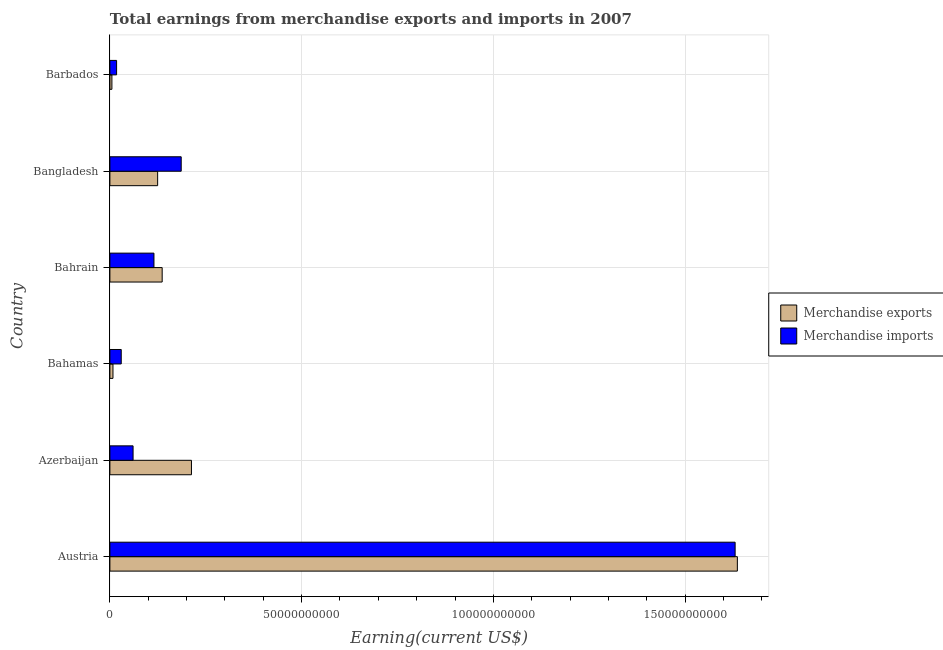How many different coloured bars are there?
Ensure brevity in your answer.  2. Are the number of bars per tick equal to the number of legend labels?
Offer a terse response. Yes. How many bars are there on the 6th tick from the top?
Ensure brevity in your answer.  2. In how many cases, is the number of bars for a given country not equal to the number of legend labels?
Your answer should be very brief. 0. What is the earnings from merchandise imports in Azerbaijan?
Keep it short and to the point. 6.05e+09. Across all countries, what is the maximum earnings from merchandise imports?
Keep it short and to the point. 1.63e+11. Across all countries, what is the minimum earnings from merchandise imports?
Offer a very short reply. 1.75e+09. In which country was the earnings from merchandise imports minimum?
Give a very brief answer. Barbados. What is the total earnings from merchandise exports in the graph?
Keep it short and to the point. 2.12e+11. What is the difference between the earnings from merchandise imports in Austria and that in Bahamas?
Offer a terse response. 1.60e+11. What is the difference between the earnings from merchandise exports in Bangladesh and the earnings from merchandise imports in Bahamas?
Ensure brevity in your answer.  9.50e+09. What is the average earnings from merchandise exports per country?
Keep it short and to the point. 3.54e+1. What is the difference between the earnings from merchandise exports and earnings from merchandise imports in Bahrain?
Provide a short and direct response. 2.15e+09. In how many countries, is the earnings from merchandise exports greater than 80000000000 US$?
Provide a short and direct response. 1. What is the ratio of the earnings from merchandise imports in Bahamas to that in Bahrain?
Provide a short and direct response. 0.26. Is the difference between the earnings from merchandise exports in Azerbaijan and Barbados greater than the difference between the earnings from merchandise imports in Azerbaijan and Barbados?
Provide a succinct answer. Yes. What is the difference between the highest and the second highest earnings from merchandise exports?
Make the answer very short. 1.42e+11. What is the difference between the highest and the lowest earnings from merchandise exports?
Keep it short and to the point. 1.63e+11. How many countries are there in the graph?
Provide a succinct answer. 6. What is the difference between two consecutive major ticks on the X-axis?
Provide a short and direct response. 5.00e+1. Does the graph contain grids?
Keep it short and to the point. Yes. How are the legend labels stacked?
Make the answer very short. Vertical. What is the title of the graph?
Provide a short and direct response. Total earnings from merchandise exports and imports in 2007. Does "Borrowers" appear as one of the legend labels in the graph?
Your answer should be very brief. No. What is the label or title of the X-axis?
Offer a terse response. Earning(current US$). What is the label or title of the Y-axis?
Offer a terse response. Country. What is the Earning(current US$) of Merchandise exports in Austria?
Provide a succinct answer. 1.64e+11. What is the Earning(current US$) of Merchandise imports in Austria?
Your answer should be compact. 1.63e+11. What is the Earning(current US$) in Merchandise exports in Azerbaijan?
Make the answer very short. 2.13e+1. What is the Earning(current US$) of Merchandise imports in Azerbaijan?
Keep it short and to the point. 6.05e+09. What is the Earning(current US$) in Merchandise exports in Bahamas?
Your answer should be compact. 8.02e+08. What is the Earning(current US$) of Merchandise imports in Bahamas?
Your answer should be very brief. 2.96e+09. What is the Earning(current US$) of Merchandise exports in Bahrain?
Make the answer very short. 1.36e+1. What is the Earning(current US$) of Merchandise imports in Bahrain?
Your answer should be very brief. 1.15e+1. What is the Earning(current US$) in Merchandise exports in Bangladesh?
Offer a terse response. 1.25e+1. What is the Earning(current US$) of Merchandise imports in Bangladesh?
Provide a succinct answer. 1.86e+1. What is the Earning(current US$) of Merchandise exports in Barbados?
Provide a short and direct response. 5.24e+08. What is the Earning(current US$) in Merchandise imports in Barbados?
Ensure brevity in your answer.  1.75e+09. Across all countries, what is the maximum Earning(current US$) in Merchandise exports?
Offer a terse response. 1.64e+11. Across all countries, what is the maximum Earning(current US$) of Merchandise imports?
Offer a terse response. 1.63e+11. Across all countries, what is the minimum Earning(current US$) in Merchandise exports?
Ensure brevity in your answer.  5.24e+08. Across all countries, what is the minimum Earning(current US$) in Merchandise imports?
Your answer should be very brief. 1.75e+09. What is the total Earning(current US$) of Merchandise exports in the graph?
Your answer should be very brief. 2.12e+11. What is the total Earning(current US$) in Merchandise imports in the graph?
Provide a short and direct response. 2.04e+11. What is the difference between the Earning(current US$) in Merchandise exports in Austria and that in Azerbaijan?
Your response must be concise. 1.42e+11. What is the difference between the Earning(current US$) of Merchandise imports in Austria and that in Azerbaijan?
Offer a terse response. 1.57e+11. What is the difference between the Earning(current US$) of Merchandise exports in Austria and that in Bahamas?
Ensure brevity in your answer.  1.63e+11. What is the difference between the Earning(current US$) in Merchandise imports in Austria and that in Bahamas?
Your answer should be compact. 1.60e+11. What is the difference between the Earning(current US$) in Merchandise exports in Austria and that in Bahrain?
Your answer should be very brief. 1.50e+11. What is the difference between the Earning(current US$) of Merchandise imports in Austria and that in Bahrain?
Offer a very short reply. 1.52e+11. What is the difference between the Earning(current US$) in Merchandise exports in Austria and that in Bangladesh?
Provide a short and direct response. 1.51e+11. What is the difference between the Earning(current US$) of Merchandise imports in Austria and that in Bangladesh?
Keep it short and to the point. 1.44e+11. What is the difference between the Earning(current US$) in Merchandise exports in Austria and that in Barbados?
Your response must be concise. 1.63e+11. What is the difference between the Earning(current US$) of Merchandise imports in Austria and that in Barbados?
Provide a succinct answer. 1.61e+11. What is the difference between the Earning(current US$) of Merchandise exports in Azerbaijan and that in Bahamas?
Offer a very short reply. 2.05e+1. What is the difference between the Earning(current US$) of Merchandise imports in Azerbaijan and that in Bahamas?
Your response must be concise. 3.09e+09. What is the difference between the Earning(current US$) of Merchandise exports in Azerbaijan and that in Bahrain?
Your answer should be compact. 7.64e+09. What is the difference between the Earning(current US$) in Merchandise imports in Azerbaijan and that in Bahrain?
Provide a succinct answer. -5.44e+09. What is the difference between the Earning(current US$) in Merchandise exports in Azerbaijan and that in Bangladesh?
Your answer should be compact. 8.82e+09. What is the difference between the Earning(current US$) in Merchandise imports in Azerbaijan and that in Bangladesh?
Your answer should be compact. -1.26e+1. What is the difference between the Earning(current US$) in Merchandise exports in Azerbaijan and that in Barbados?
Your response must be concise. 2.07e+1. What is the difference between the Earning(current US$) in Merchandise imports in Azerbaijan and that in Barbados?
Your answer should be very brief. 4.30e+09. What is the difference between the Earning(current US$) in Merchandise exports in Bahamas and that in Bahrain?
Offer a terse response. -1.28e+1. What is the difference between the Earning(current US$) in Merchandise imports in Bahamas and that in Bahrain?
Your answer should be compact. -8.53e+09. What is the difference between the Earning(current US$) of Merchandise exports in Bahamas and that in Bangladesh?
Offer a very short reply. -1.17e+1. What is the difference between the Earning(current US$) of Merchandise imports in Bahamas and that in Bangladesh?
Offer a very short reply. -1.56e+1. What is the difference between the Earning(current US$) of Merchandise exports in Bahamas and that in Barbados?
Keep it short and to the point. 2.78e+08. What is the difference between the Earning(current US$) in Merchandise imports in Bahamas and that in Barbados?
Ensure brevity in your answer.  1.21e+09. What is the difference between the Earning(current US$) of Merchandise exports in Bahrain and that in Bangladesh?
Offer a terse response. 1.18e+09. What is the difference between the Earning(current US$) in Merchandise imports in Bahrain and that in Bangladesh?
Provide a short and direct response. -7.11e+09. What is the difference between the Earning(current US$) in Merchandise exports in Bahrain and that in Barbados?
Keep it short and to the point. 1.31e+1. What is the difference between the Earning(current US$) in Merchandise imports in Bahrain and that in Barbados?
Ensure brevity in your answer.  9.74e+09. What is the difference between the Earning(current US$) of Merchandise exports in Bangladesh and that in Barbados?
Your answer should be very brief. 1.19e+1. What is the difference between the Earning(current US$) in Merchandise imports in Bangladesh and that in Barbados?
Your answer should be compact. 1.68e+1. What is the difference between the Earning(current US$) of Merchandise exports in Austria and the Earning(current US$) of Merchandise imports in Azerbaijan?
Provide a succinct answer. 1.58e+11. What is the difference between the Earning(current US$) of Merchandise exports in Austria and the Earning(current US$) of Merchandise imports in Bahamas?
Give a very brief answer. 1.61e+11. What is the difference between the Earning(current US$) of Merchandise exports in Austria and the Earning(current US$) of Merchandise imports in Bahrain?
Keep it short and to the point. 1.52e+11. What is the difference between the Earning(current US$) in Merchandise exports in Austria and the Earning(current US$) in Merchandise imports in Bangladesh?
Provide a succinct answer. 1.45e+11. What is the difference between the Earning(current US$) of Merchandise exports in Austria and the Earning(current US$) of Merchandise imports in Barbados?
Ensure brevity in your answer.  1.62e+11. What is the difference between the Earning(current US$) in Merchandise exports in Azerbaijan and the Earning(current US$) in Merchandise imports in Bahamas?
Provide a short and direct response. 1.83e+1. What is the difference between the Earning(current US$) in Merchandise exports in Azerbaijan and the Earning(current US$) in Merchandise imports in Bahrain?
Give a very brief answer. 9.78e+09. What is the difference between the Earning(current US$) in Merchandise exports in Azerbaijan and the Earning(current US$) in Merchandise imports in Bangladesh?
Provide a short and direct response. 2.67e+09. What is the difference between the Earning(current US$) of Merchandise exports in Azerbaijan and the Earning(current US$) of Merchandise imports in Barbados?
Give a very brief answer. 1.95e+1. What is the difference between the Earning(current US$) in Merchandise exports in Bahamas and the Earning(current US$) in Merchandise imports in Bahrain?
Provide a short and direct response. -1.07e+1. What is the difference between the Earning(current US$) of Merchandise exports in Bahamas and the Earning(current US$) of Merchandise imports in Bangladesh?
Your answer should be very brief. -1.78e+1. What is the difference between the Earning(current US$) in Merchandise exports in Bahamas and the Earning(current US$) in Merchandise imports in Barbados?
Make the answer very short. -9.44e+08. What is the difference between the Earning(current US$) of Merchandise exports in Bahrain and the Earning(current US$) of Merchandise imports in Bangladesh?
Offer a terse response. -4.96e+09. What is the difference between the Earning(current US$) in Merchandise exports in Bahrain and the Earning(current US$) in Merchandise imports in Barbados?
Provide a succinct answer. 1.19e+1. What is the difference between the Earning(current US$) of Merchandise exports in Bangladesh and the Earning(current US$) of Merchandise imports in Barbados?
Provide a succinct answer. 1.07e+1. What is the average Earning(current US$) in Merchandise exports per country?
Your answer should be compact. 3.54e+1. What is the average Earning(current US$) of Merchandise imports per country?
Provide a succinct answer. 3.40e+1. What is the difference between the Earning(current US$) in Merchandise exports and Earning(current US$) in Merchandise imports in Austria?
Give a very brief answer. 5.83e+08. What is the difference between the Earning(current US$) of Merchandise exports and Earning(current US$) of Merchandise imports in Azerbaijan?
Keep it short and to the point. 1.52e+1. What is the difference between the Earning(current US$) in Merchandise exports and Earning(current US$) in Merchandise imports in Bahamas?
Offer a terse response. -2.15e+09. What is the difference between the Earning(current US$) of Merchandise exports and Earning(current US$) of Merchandise imports in Bahrain?
Offer a terse response. 2.15e+09. What is the difference between the Earning(current US$) of Merchandise exports and Earning(current US$) of Merchandise imports in Bangladesh?
Your response must be concise. -6.14e+09. What is the difference between the Earning(current US$) of Merchandise exports and Earning(current US$) of Merchandise imports in Barbados?
Your answer should be very brief. -1.22e+09. What is the ratio of the Earning(current US$) in Merchandise exports in Austria to that in Azerbaijan?
Keep it short and to the point. 7.69. What is the ratio of the Earning(current US$) in Merchandise imports in Austria to that in Azerbaijan?
Keep it short and to the point. 26.97. What is the ratio of the Earning(current US$) in Merchandise exports in Austria to that in Bahamas?
Provide a succinct answer. 204.04. What is the ratio of the Earning(current US$) of Merchandise imports in Austria to that in Bahamas?
Offer a very short reply. 55.15. What is the ratio of the Earning(current US$) of Merchandise exports in Austria to that in Bahrain?
Offer a terse response. 12. What is the ratio of the Earning(current US$) in Merchandise imports in Austria to that in Bahrain?
Offer a terse response. 14.19. What is the ratio of the Earning(current US$) in Merchandise exports in Austria to that in Bangladesh?
Your answer should be very brief. 13.14. What is the ratio of the Earning(current US$) of Merchandise imports in Austria to that in Bangladesh?
Your answer should be compact. 8.77. What is the ratio of the Earning(current US$) of Merchandise exports in Austria to that in Barbados?
Keep it short and to the point. 312.36. What is the ratio of the Earning(current US$) in Merchandise imports in Austria to that in Barbados?
Provide a short and direct response. 93.37. What is the ratio of the Earning(current US$) of Merchandise exports in Azerbaijan to that in Bahamas?
Offer a terse response. 26.52. What is the ratio of the Earning(current US$) in Merchandise imports in Azerbaijan to that in Bahamas?
Your response must be concise. 2.04. What is the ratio of the Earning(current US$) of Merchandise exports in Azerbaijan to that in Bahrain?
Provide a succinct answer. 1.56. What is the ratio of the Earning(current US$) in Merchandise imports in Azerbaijan to that in Bahrain?
Your answer should be very brief. 0.53. What is the ratio of the Earning(current US$) of Merchandise exports in Azerbaijan to that in Bangladesh?
Your answer should be compact. 1.71. What is the ratio of the Earning(current US$) of Merchandise imports in Azerbaijan to that in Bangladesh?
Keep it short and to the point. 0.33. What is the ratio of the Earning(current US$) of Merchandise exports in Azerbaijan to that in Barbados?
Give a very brief answer. 40.6. What is the ratio of the Earning(current US$) of Merchandise imports in Azerbaijan to that in Barbados?
Your answer should be very brief. 3.46. What is the ratio of the Earning(current US$) of Merchandise exports in Bahamas to that in Bahrain?
Provide a succinct answer. 0.06. What is the ratio of the Earning(current US$) in Merchandise imports in Bahamas to that in Bahrain?
Offer a terse response. 0.26. What is the ratio of the Earning(current US$) of Merchandise exports in Bahamas to that in Bangladesh?
Your answer should be very brief. 0.06. What is the ratio of the Earning(current US$) in Merchandise imports in Bahamas to that in Bangladesh?
Give a very brief answer. 0.16. What is the ratio of the Earning(current US$) in Merchandise exports in Bahamas to that in Barbados?
Your response must be concise. 1.53. What is the ratio of the Earning(current US$) in Merchandise imports in Bahamas to that in Barbados?
Offer a very short reply. 1.69. What is the ratio of the Earning(current US$) of Merchandise exports in Bahrain to that in Bangladesh?
Provide a succinct answer. 1.09. What is the ratio of the Earning(current US$) in Merchandise imports in Bahrain to that in Bangladesh?
Your response must be concise. 0.62. What is the ratio of the Earning(current US$) in Merchandise exports in Bahrain to that in Barbados?
Offer a terse response. 26.03. What is the ratio of the Earning(current US$) in Merchandise imports in Bahrain to that in Barbados?
Offer a very short reply. 6.58. What is the ratio of the Earning(current US$) of Merchandise exports in Bangladesh to that in Barbados?
Your answer should be compact. 23.77. What is the ratio of the Earning(current US$) of Merchandise imports in Bangladesh to that in Barbados?
Your response must be concise. 10.65. What is the difference between the highest and the second highest Earning(current US$) of Merchandise exports?
Give a very brief answer. 1.42e+11. What is the difference between the highest and the second highest Earning(current US$) of Merchandise imports?
Ensure brevity in your answer.  1.44e+11. What is the difference between the highest and the lowest Earning(current US$) of Merchandise exports?
Your response must be concise. 1.63e+11. What is the difference between the highest and the lowest Earning(current US$) in Merchandise imports?
Give a very brief answer. 1.61e+11. 